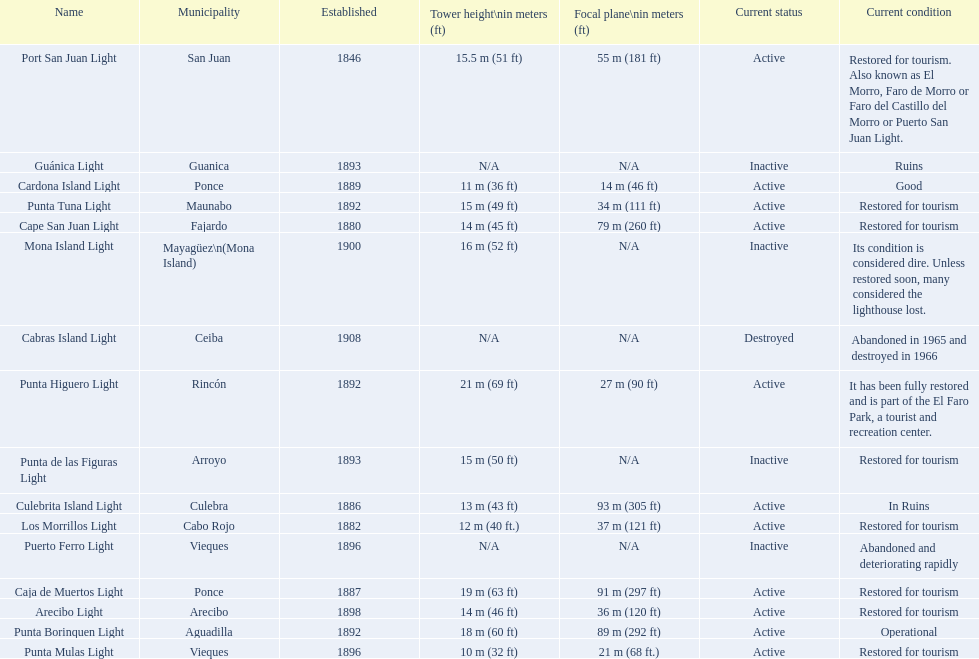Number of lighthouses that begin with the letter p 7. 